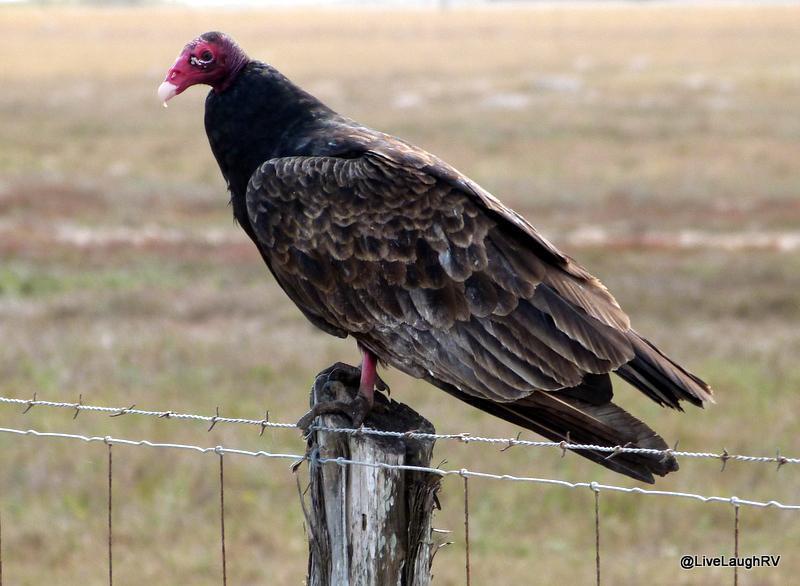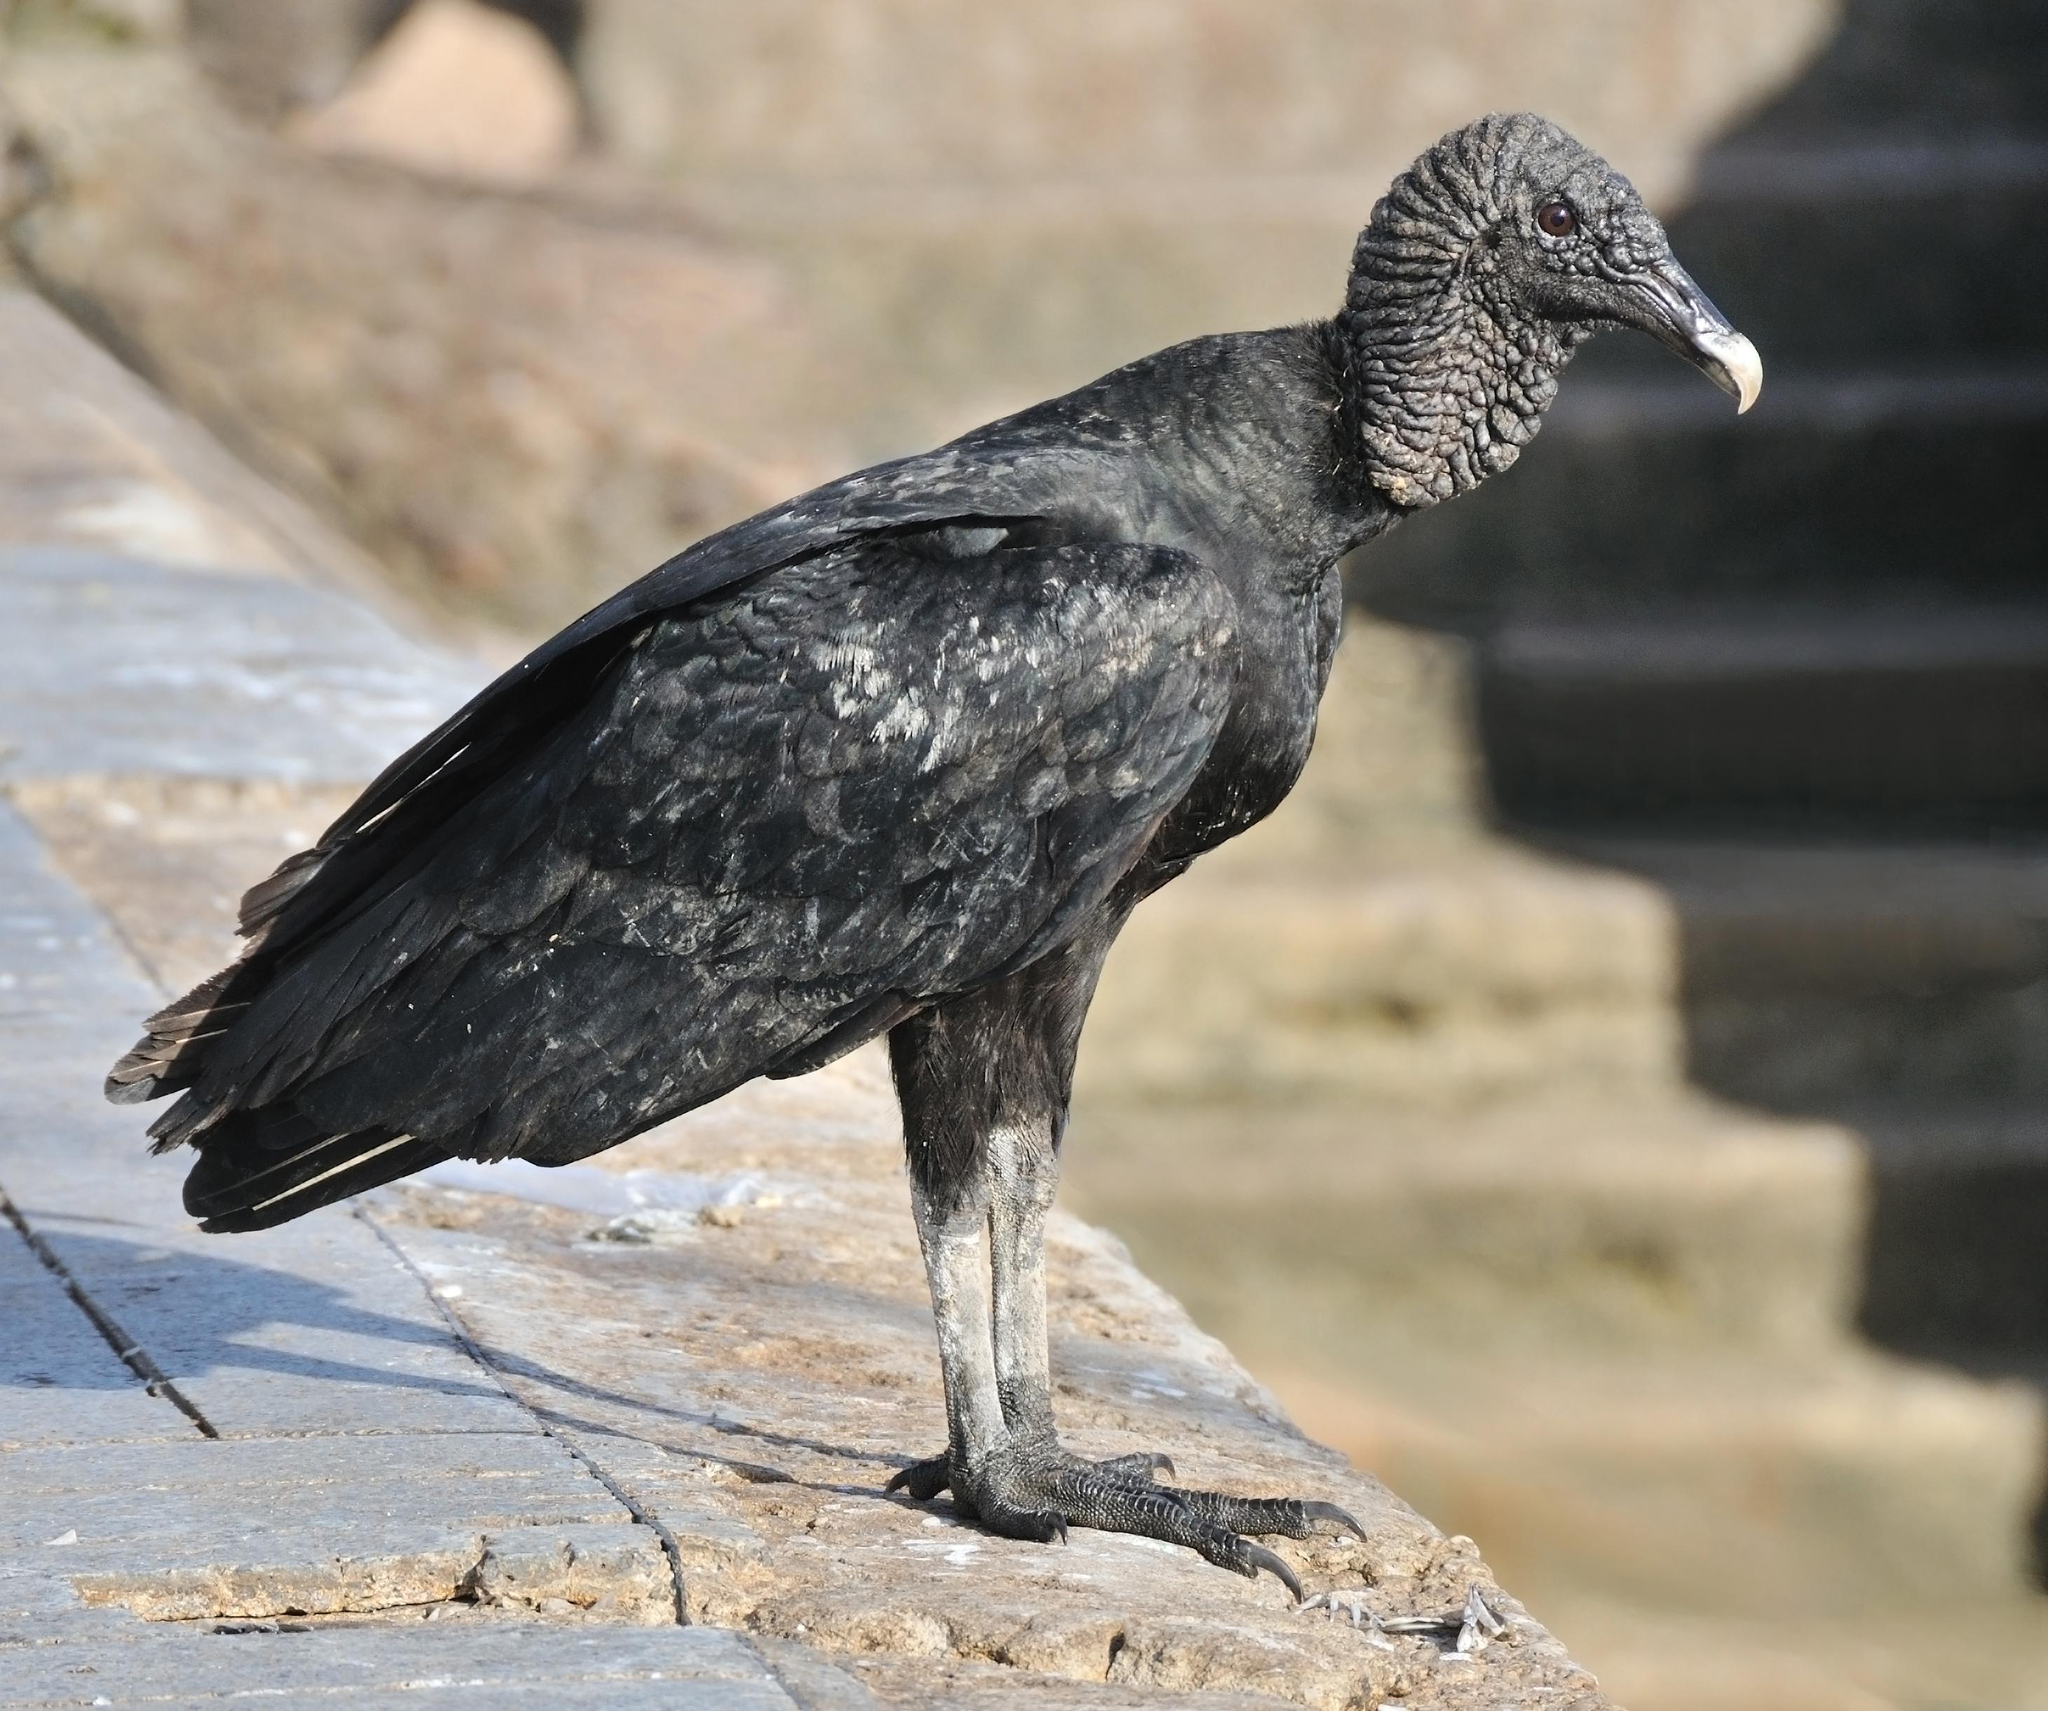The first image is the image on the left, the second image is the image on the right. Evaluate the accuracy of this statement regarding the images: "In the pair, one bird is standing on a post and the other on a flat surface.". Is it true? Answer yes or no. Yes. 